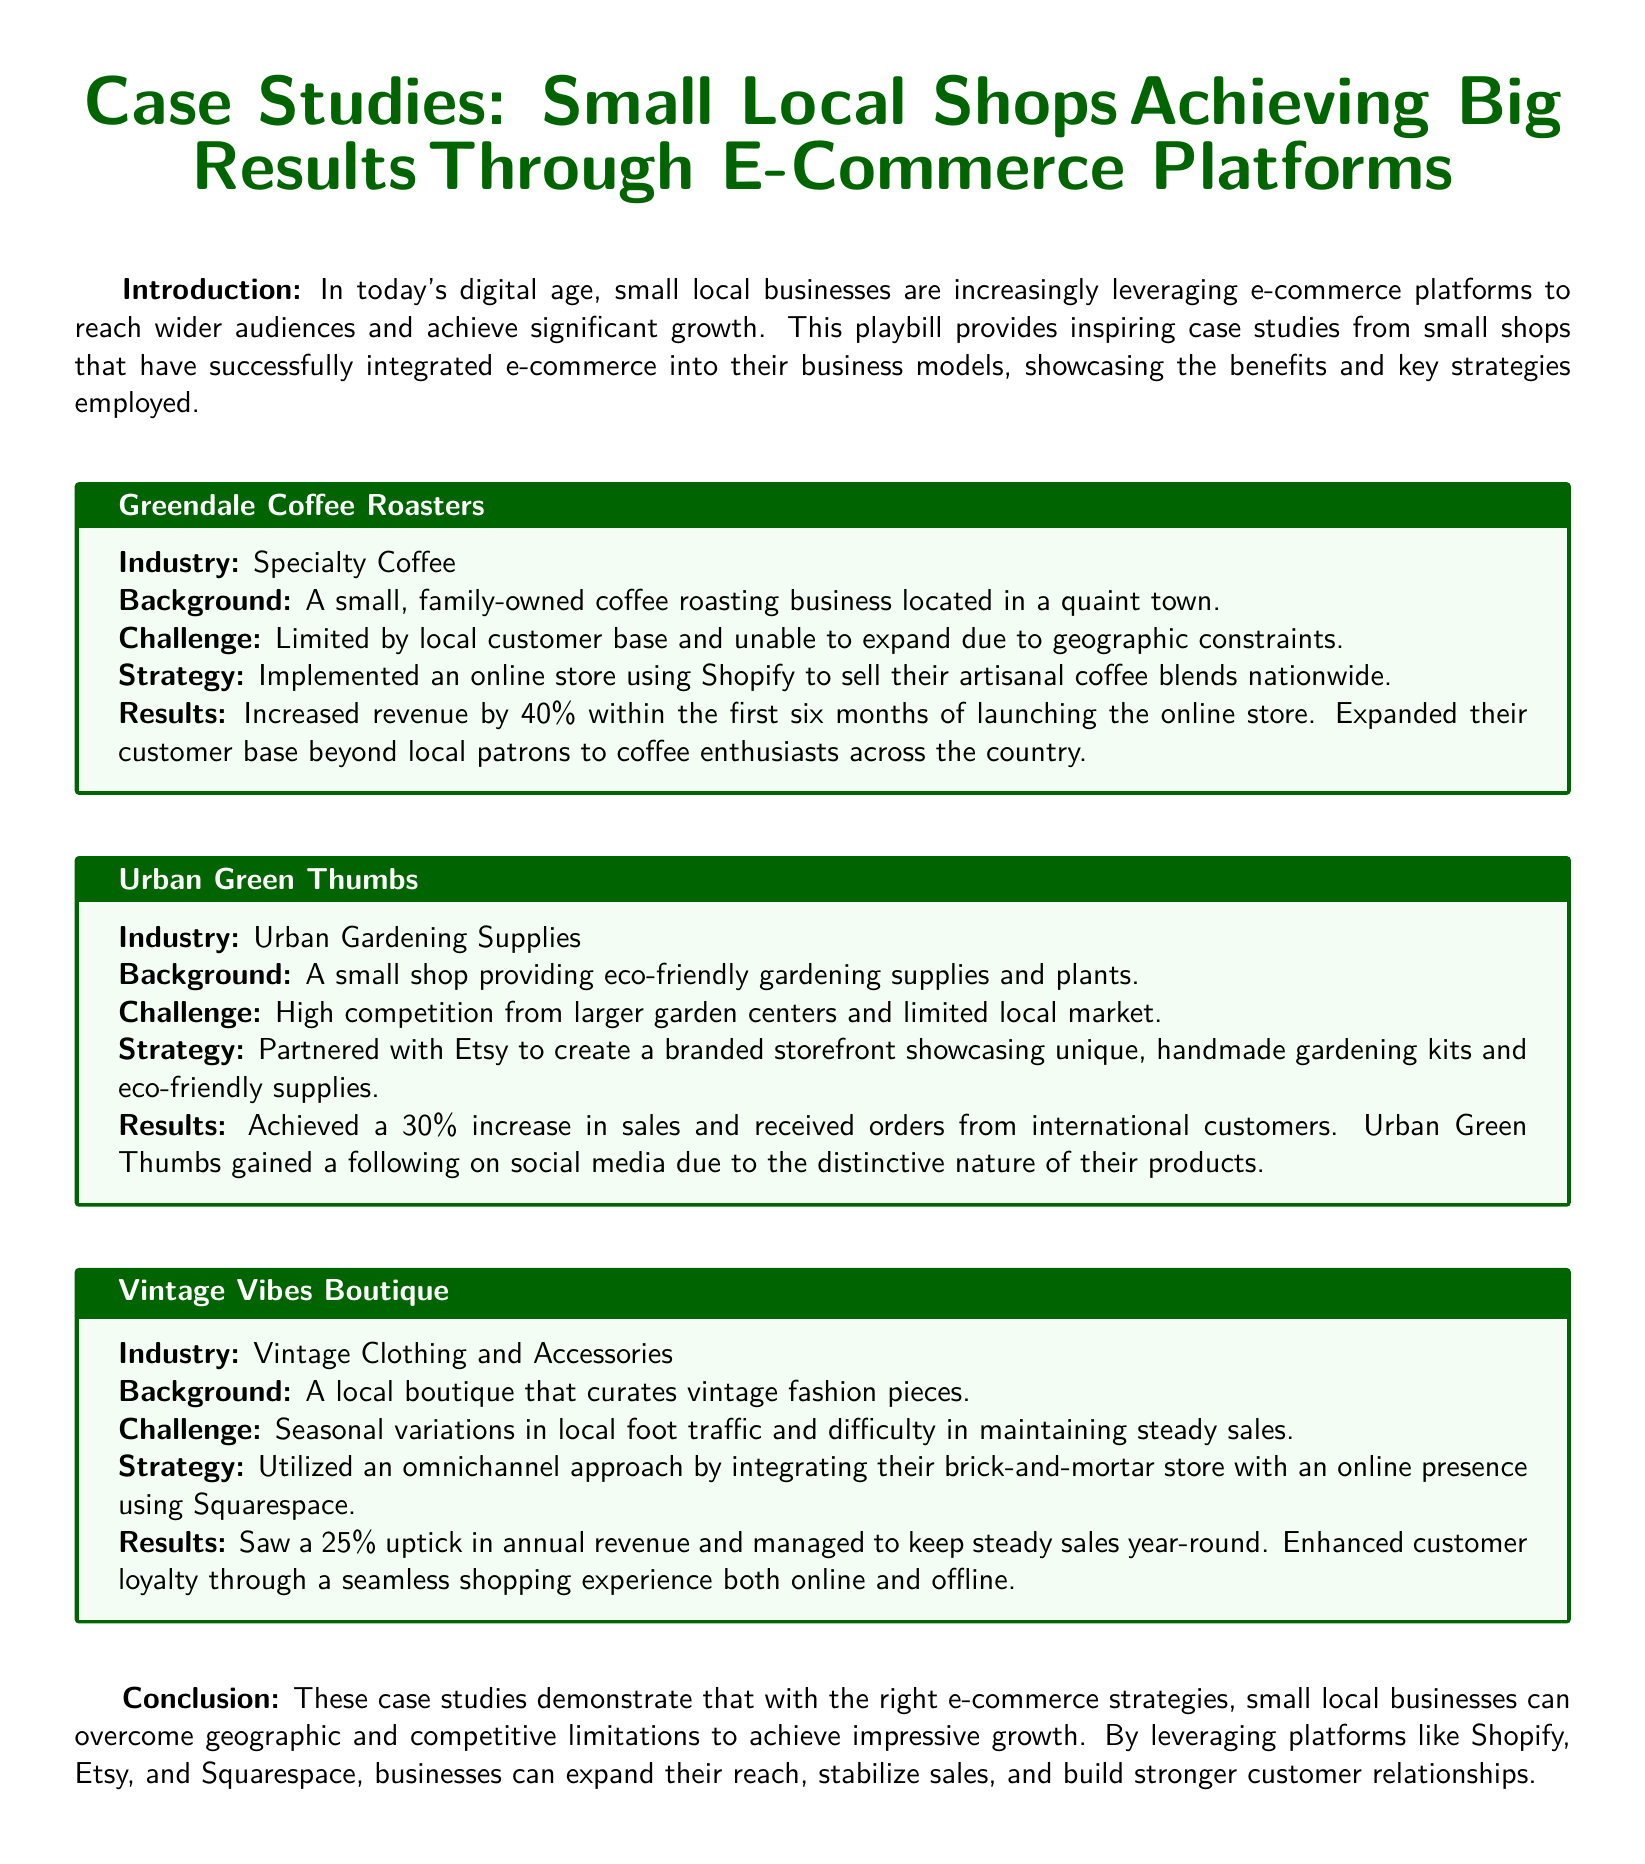What is the name of the first case study? The name of the first case study is Greendale Coffee Roasters.
Answer: Greendale Coffee Roasters What industry does Urban Green Thumbs belong to? Urban Green Thumbs is categorized under Urban Gardening Supplies.
Answer: Urban Gardening Supplies What was the increase in revenue for Greendale Coffee Roasters after launching their online store? The increase in revenue for Greendale Coffee Roasters was 40% within the first six months.
Answer: 40% Which e-commerce platform did Vintage Vibes Boutique use? Vintage Vibes Boutique utilized Squarespace for their online presence.
Answer: Squarespace What challenge did Urban Green Thumbs face? Urban Green Thumbs faced high competition from larger garden centers and a limited local market.
Answer: High competition What was the percentage increase in sales for Urban Green Thumbs? Urban Green Thumbs achieved a 30% increase in sales.
Answer: 30% What type of strategy did Vintage Vibes Boutique implement? Vintage Vibes Boutique implemented an omnichannel approach.
Answer: Omnichannel approach What is the conclusion of the document? The conclusion emphasizes that small local businesses can achieve impressive growth with the right e-commerce strategies.
Answer: Achieve impressive growth What additional benefit did Urban Green Thumbs gain through e-commerce? Urban Green Thumbs gained a following on social media due to their distinctive products.
Answer: Following on social media What was a key result for Greendale Coffee Roasters after implementing e-commerce? A key result was expanding their customer base beyond local patrons.
Answer: Expanding their customer base 